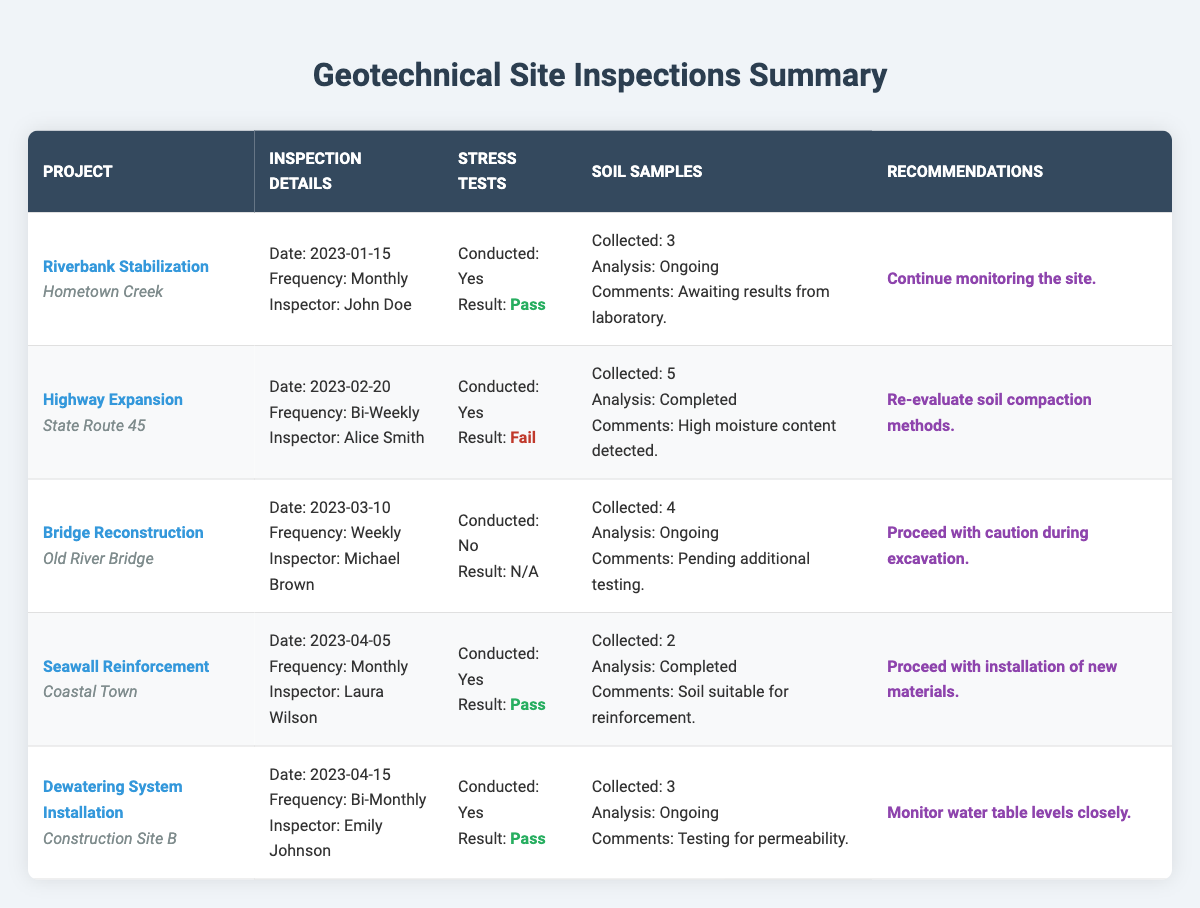What is the inspection frequency for the "Bridge Reconstruction" project? The inspection frequency for the "Bridge Reconstruction" project, as listed in the table, is "Weekly."
Answer: Weekly How many soil samples were collected for the "Highway Expansion" project? The table shows that 5 soil samples were collected for the "Highway Expansion" project.
Answer: 5 Did the "Seawall Reinforcement" project pass the stress tests? According to the results in the table, the "Seawall Reinforcement" project did pass the stress tests.
Answer: Yes How many projects have a recommendation to monitor the site? The "Riverbank Stabilization" and the "Dewatering System Installation" projects both have recommendations to monitor the site. Therefore, there are 2 projects.
Answer: 2 What was the lab analysis status of soil samples for the "Dewatering System Installation" project? The table indicates that the lab analysis for the soil samples collected during the "Dewatering System Installation" project is "Ongoing."
Answer: Ongoing Which inspector had the highest frequency of inspections? The "Bridge Reconstruction" project has a frequency of "Weekly," which is higher than the other projects. Therefore, the inspector for this project, Michael Brown, had the highest frequency.
Answer: Michael Brown Was any project in the table flagged for high moisture content? Yes, the "Highway Expansion" project was flagged with the comment "High moisture content detected."
Answer: Yes Calculate the total number of soil samples collected across all projects. Adding the soil samples collected: 3 (Riverbank Stabilization) + 5 (Highway Expansion) + 4 (Bridge Reconstruction) + 2 (Seawall Reinforcement) + 3 (Dewatering System Installation) gives a total of 17.
Answer: 17 Does the "Bridge Reconstruction" project have soil samples that are under lab analysis? Yes, the "Bridge Reconstruction" project's soil samples have the lab analysis marked as "Ongoing."
Answer: Yes What are the recommendations for the "Highway Expansion" project? The recommendation for the "Highway Expansion" project is to "Re-evaluate soil compaction methods."
Answer: Re-evaluate soil compaction methods 